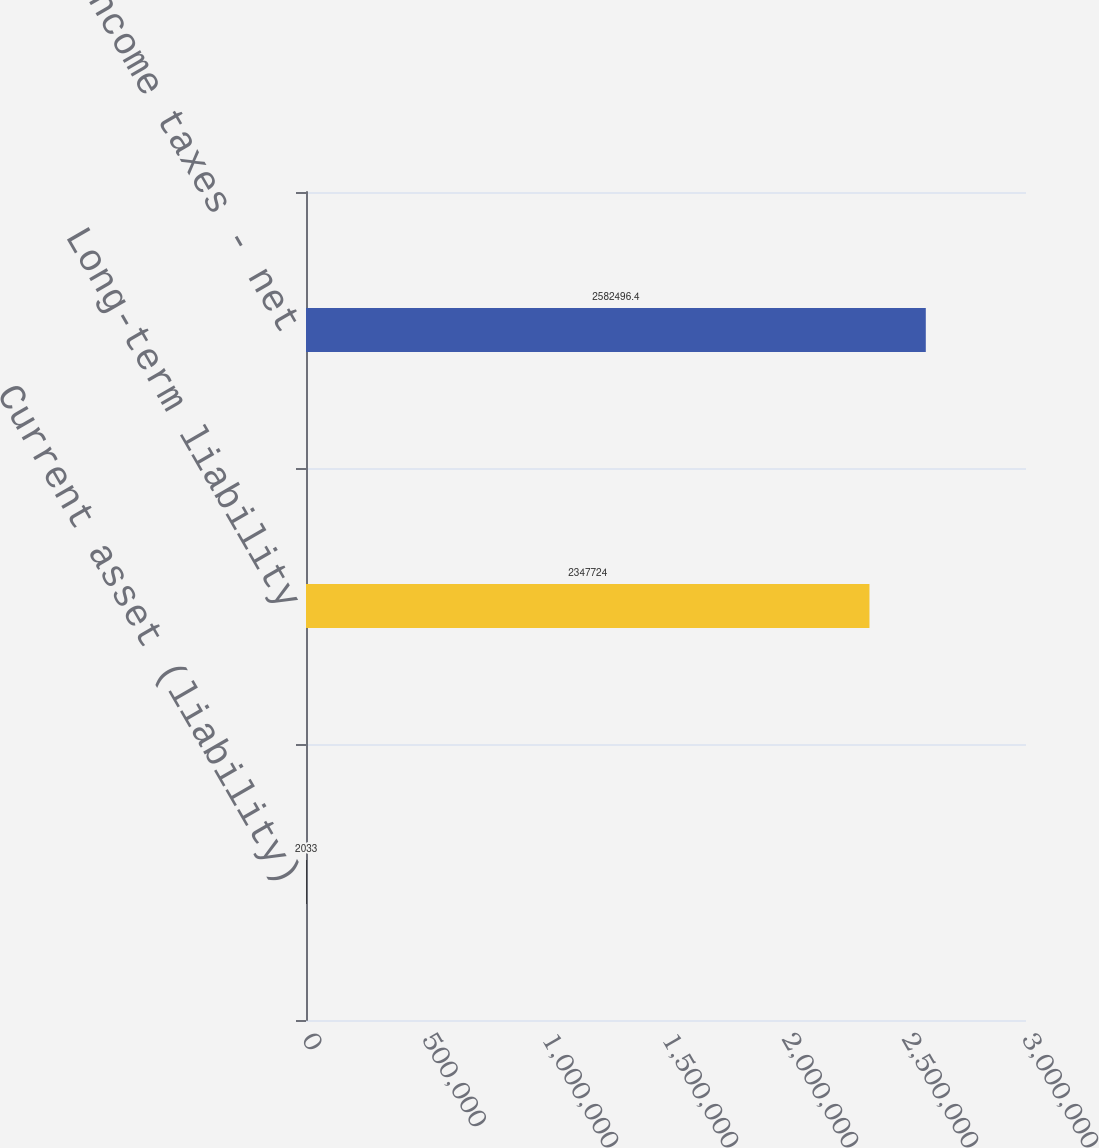Convert chart to OTSL. <chart><loc_0><loc_0><loc_500><loc_500><bar_chart><fcel>Current asset (liability)<fcel>Long-term liability<fcel>Deferred income taxes - net<nl><fcel>2033<fcel>2.34772e+06<fcel>2.5825e+06<nl></chart> 